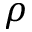Convert formula to latex. <formula><loc_0><loc_0><loc_500><loc_500>\rho</formula> 